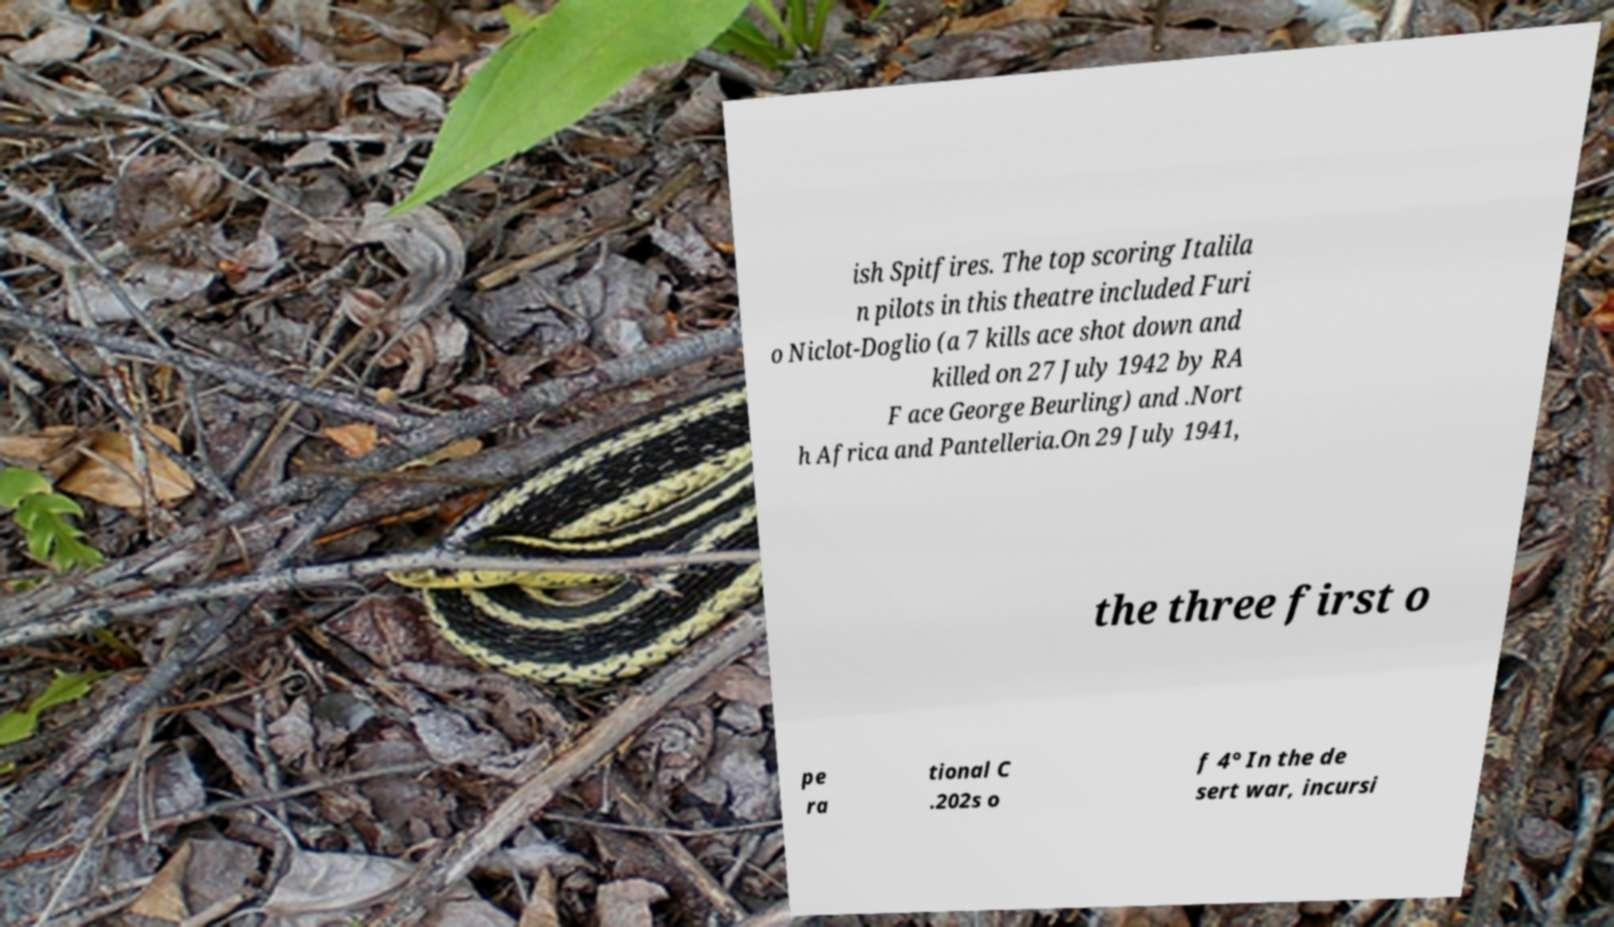There's text embedded in this image that I need extracted. Can you transcribe it verbatim? ish Spitfires. The top scoring Italila n pilots in this theatre included Furi o Niclot-Doglio (a 7 kills ace shot down and killed on 27 July 1942 by RA F ace George Beurling) and .Nort h Africa and Pantelleria.On 29 July 1941, the three first o pe ra tional C .202s o f 4° In the de sert war, incursi 